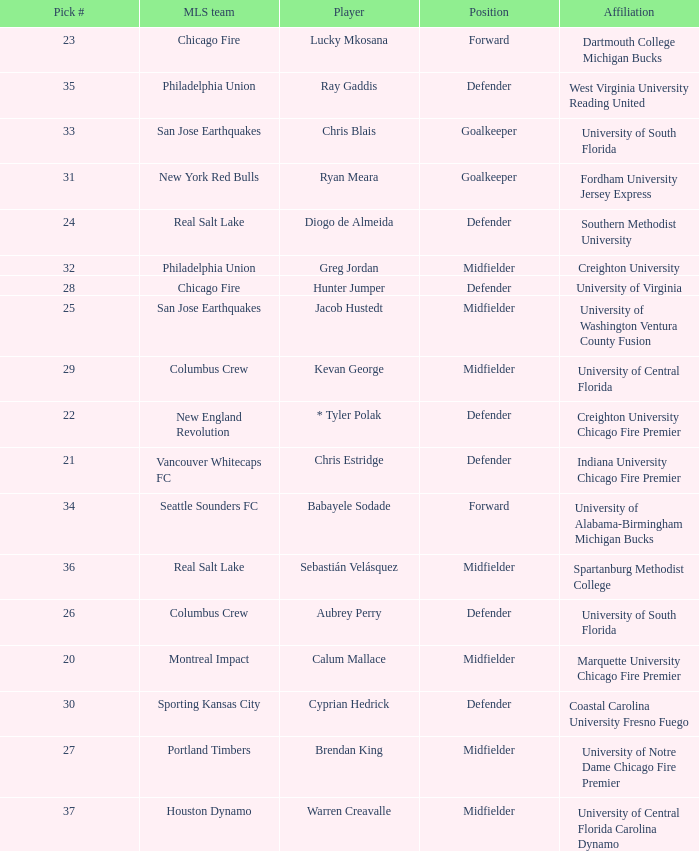What pick number did Real Salt Lake get? 24.0. 